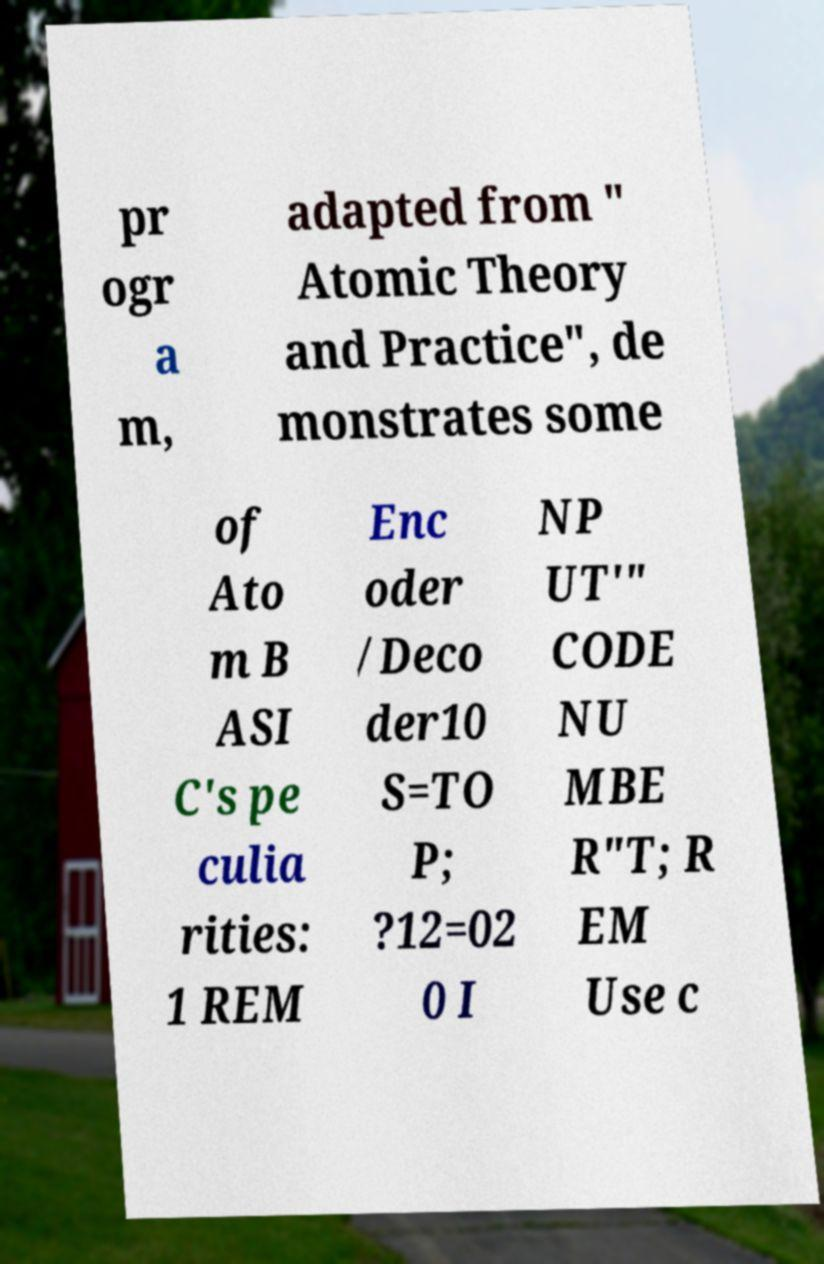Please read and relay the text visible in this image. What does it say? pr ogr a m, adapted from " Atomic Theory and Practice", de monstrates some of Ato m B ASI C's pe culia rities: 1 REM Enc oder /Deco der10 S=TO P; ?12=02 0 I NP UT'" CODE NU MBE R"T; R EM Use c 